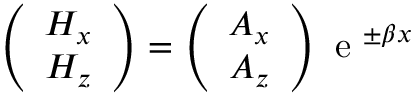<formula> <loc_0><loc_0><loc_500><loc_500>\left ( \begin{array} { c } { H _ { x } } \\ { H _ { z } } \end{array} \right ) = \left ( \begin{array} { c } { A _ { x } } \\ { A _ { z } } \end{array} \right ) e ^ { \pm \beta x }</formula> 